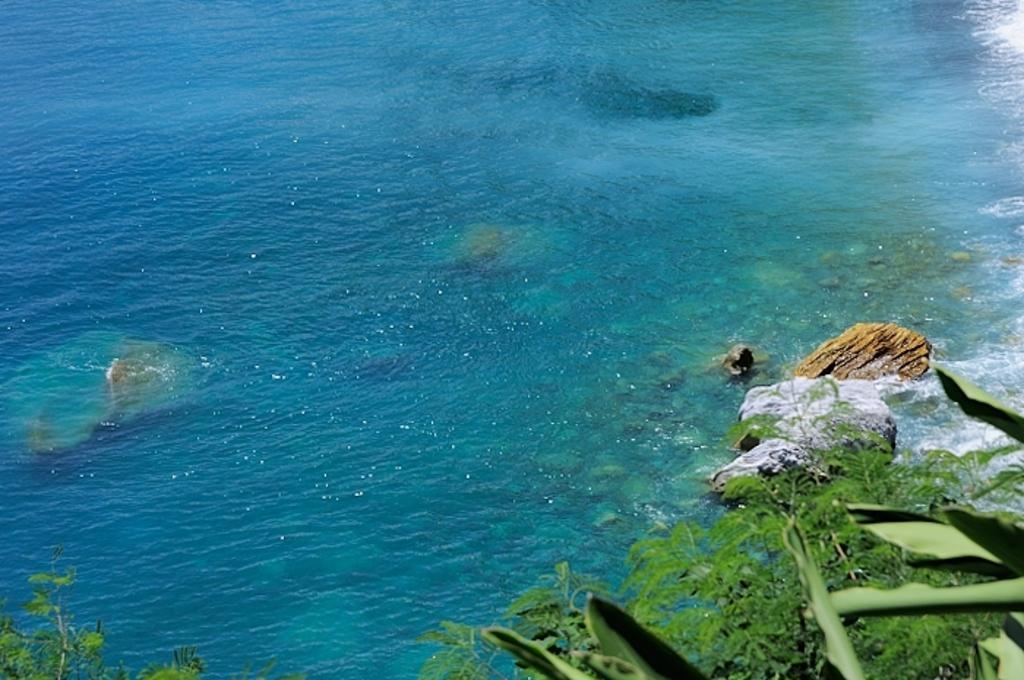Please provide a concise description of this image. In this picture we can see few rocks in the water, at the bottom of the image we can find leaves. 